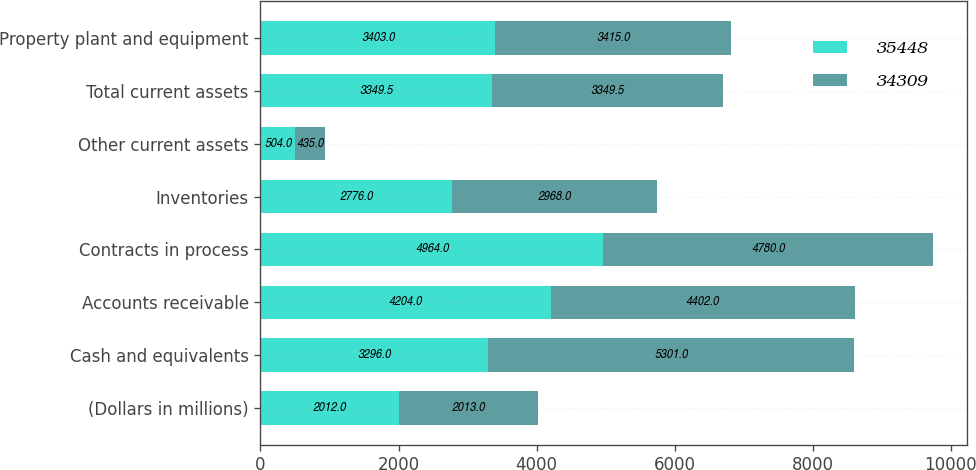Convert chart to OTSL. <chart><loc_0><loc_0><loc_500><loc_500><stacked_bar_chart><ecel><fcel>(Dollars in millions)<fcel>Cash and equivalents<fcel>Accounts receivable<fcel>Contracts in process<fcel>Inventories<fcel>Other current assets<fcel>Total current assets<fcel>Property plant and equipment<nl><fcel>35448<fcel>2012<fcel>3296<fcel>4204<fcel>4964<fcel>2776<fcel>504<fcel>3349.5<fcel>3403<nl><fcel>34309<fcel>2013<fcel>5301<fcel>4402<fcel>4780<fcel>2968<fcel>435<fcel>3349.5<fcel>3415<nl></chart> 